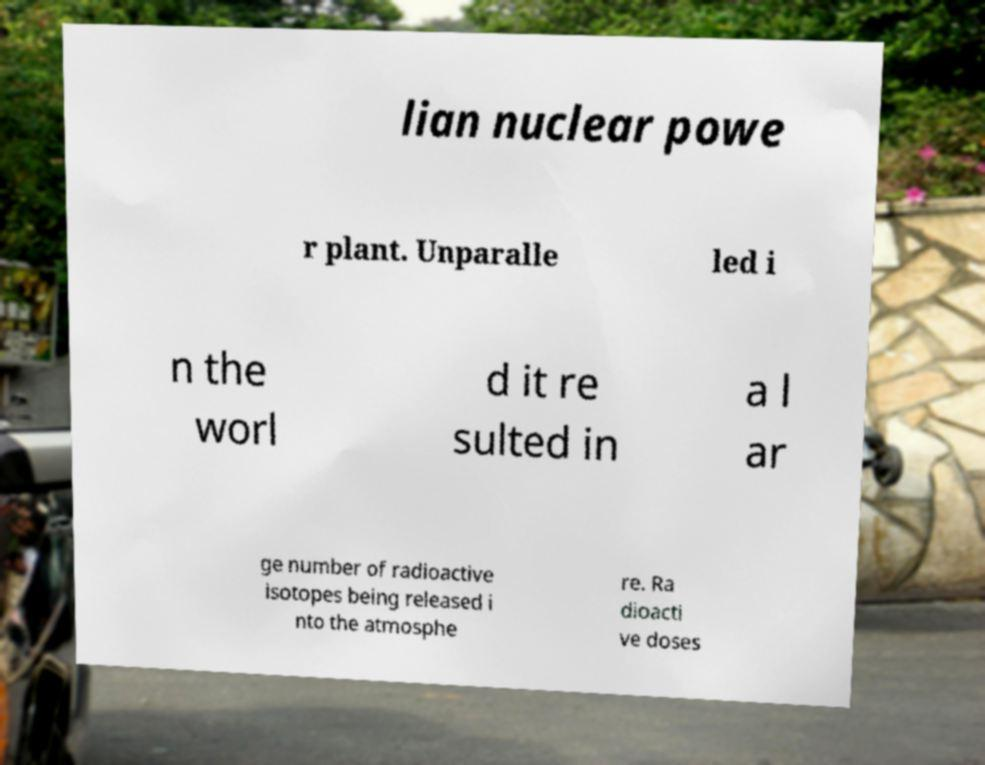Could you extract and type out the text from this image? lian nuclear powe r plant. Unparalle led i n the worl d it re sulted in a l ar ge number of radioactive isotopes being released i nto the atmosphe re. Ra dioacti ve doses 